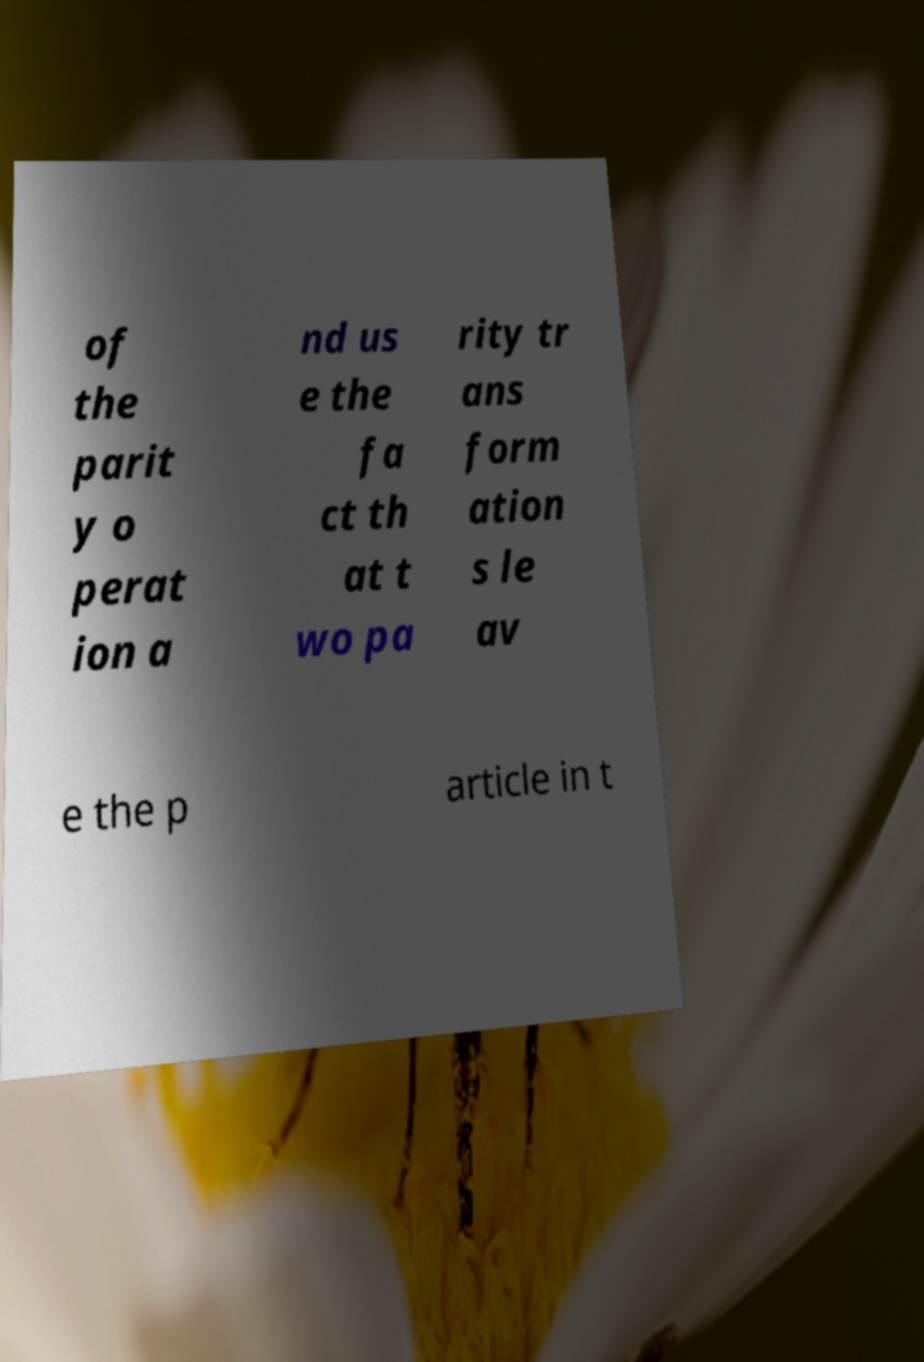There's text embedded in this image that I need extracted. Can you transcribe it verbatim? of the parit y o perat ion a nd us e the fa ct th at t wo pa rity tr ans form ation s le av e the p article in t 